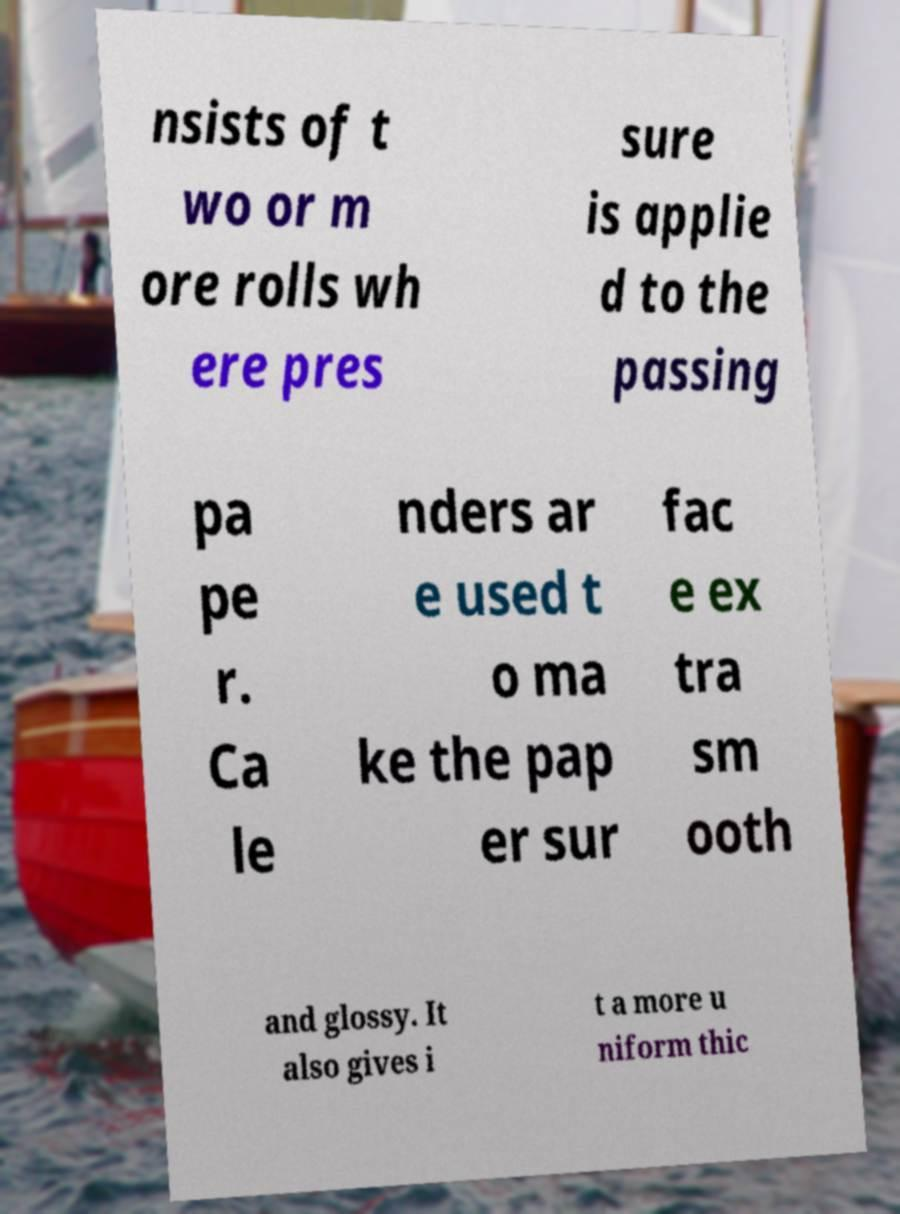For documentation purposes, I need the text within this image transcribed. Could you provide that? nsists of t wo or m ore rolls wh ere pres sure is applie d to the passing pa pe r. Ca le nders ar e used t o ma ke the pap er sur fac e ex tra sm ooth and glossy. It also gives i t a more u niform thic 